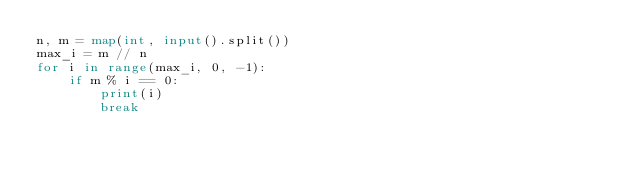Convert code to text. <code><loc_0><loc_0><loc_500><loc_500><_Python_>n, m = map(int, input().split())
max_i = m // n
for i in range(max_i, 0, -1):
    if m % i == 0:
        print(i)
        break
</code> 